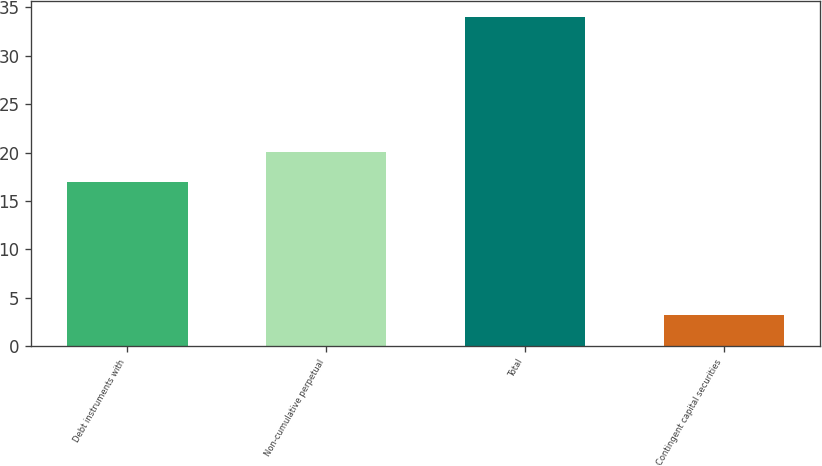Convert chart to OTSL. <chart><loc_0><loc_0><loc_500><loc_500><bar_chart><fcel>Debt instruments with<fcel>Non-cumulative perpetual<fcel>Total<fcel>Contingent capital securities<nl><fcel>17<fcel>20.08<fcel>34<fcel>3.2<nl></chart> 